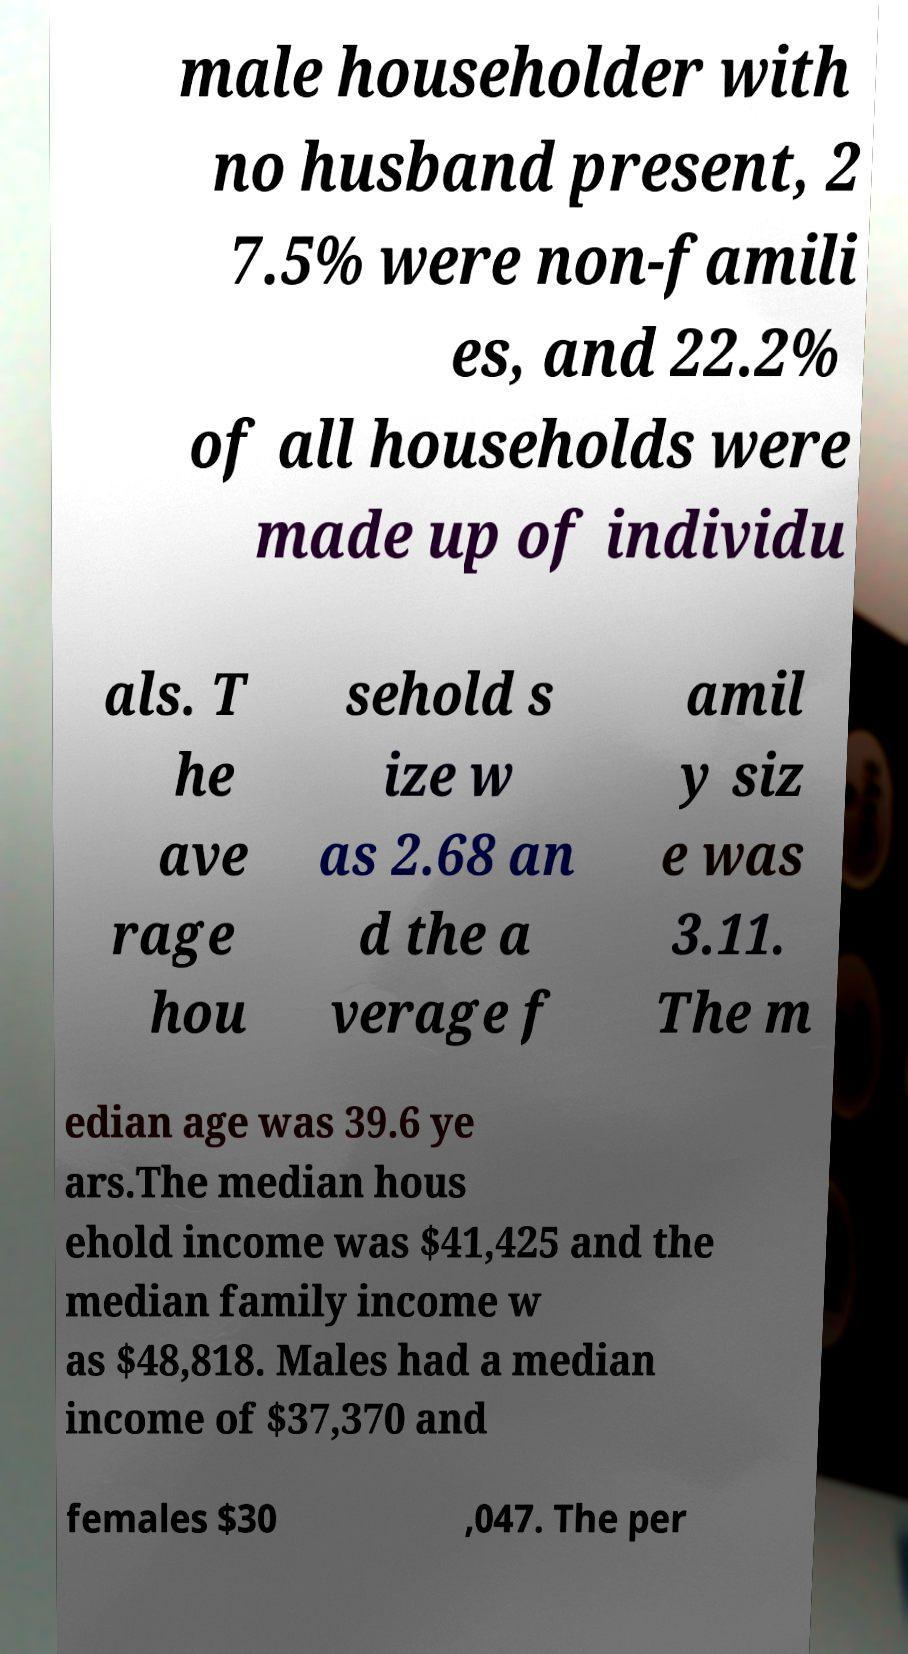Could you extract and type out the text from this image? male householder with no husband present, 2 7.5% were non-famili es, and 22.2% of all households were made up of individu als. T he ave rage hou sehold s ize w as 2.68 an d the a verage f amil y siz e was 3.11. The m edian age was 39.6 ye ars.The median hous ehold income was $41,425 and the median family income w as $48,818. Males had a median income of $37,370 and females $30 ,047. The per 